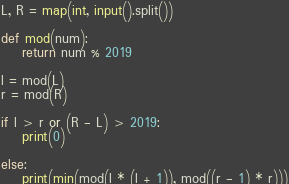Convert code to text. <code><loc_0><loc_0><loc_500><loc_500><_Python_>L, R = map(int, input().split())

def mod(num):
    return num % 2019

l = mod(L)
r = mod(R)

if l > r or (R - L) > 2019:
    print(0)

else:
    print(min(mod(l * (l + 1)), mod((r - 1) * r)))
</code> 